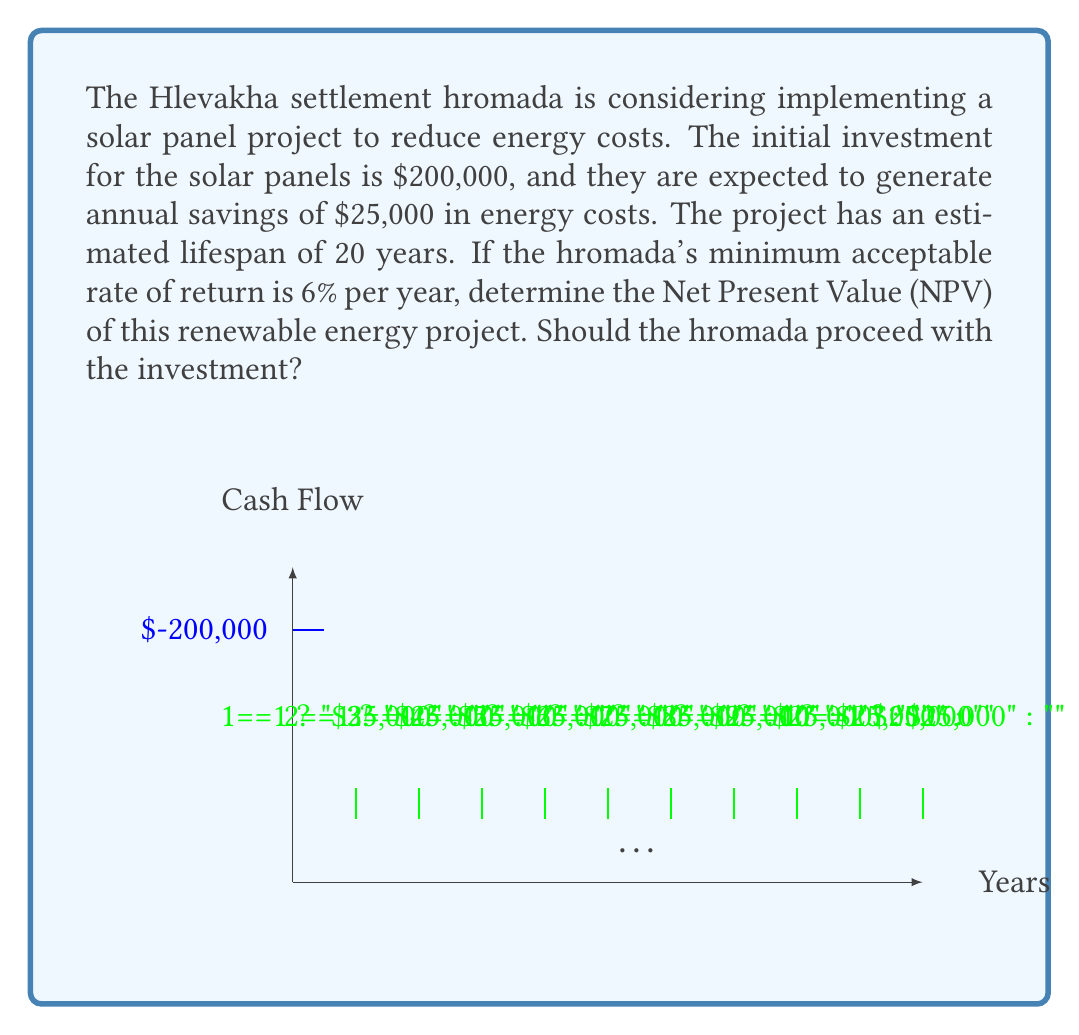Can you answer this question? To determine the Net Present Value (NPV) of the solar panel project, we need to calculate the present value of all future cash flows and subtract the initial investment. Let's approach this step-by-step:

1) The initial investment (I) is $200,000.

2) The annual savings (A) are $25,000 for 20 years.

3) The discount rate (r) is 6% or 0.06.

4) We can use the formula for the present value of an annuity:

   $$ PV_{annuity} = A \cdot \frac{1 - (1+r)^{-n}}{r} $$

   Where n is the number of years (20 in this case).

5) Let's calculate:

   $$ PV_{annuity} = 25000 \cdot \frac{1 - (1+0.06)^{-20}}{0.06} $$

   $$ = 25000 \cdot \frac{1 - 0.3118}{0.06} $$

   $$ = 25000 \cdot 11.4699 $$

   $$ = 286,747.50 $$

6) Now, we can calculate the NPV by subtracting the initial investment:

   $$ NPV = PV_{annuity} - I $$

   $$ = 286,747.50 - 200,000 $$

   $$ = 86,747.50 $$

7) Since the NPV is positive, this indicates that the project is financially viable and should be accepted.
Answer: $86,747.50; Yes, proceed with the investment. 